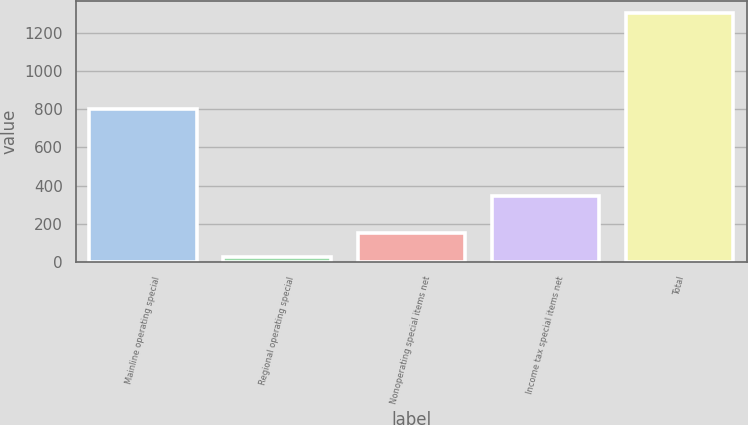<chart> <loc_0><loc_0><loc_500><loc_500><bar_chart><fcel>Mainline operating special<fcel>Regional operating special<fcel>Nonoperating special items net<fcel>Income tax special items net<fcel>Total<nl><fcel>800<fcel>24<fcel>151.8<fcel>346<fcel>1302<nl></chart> 